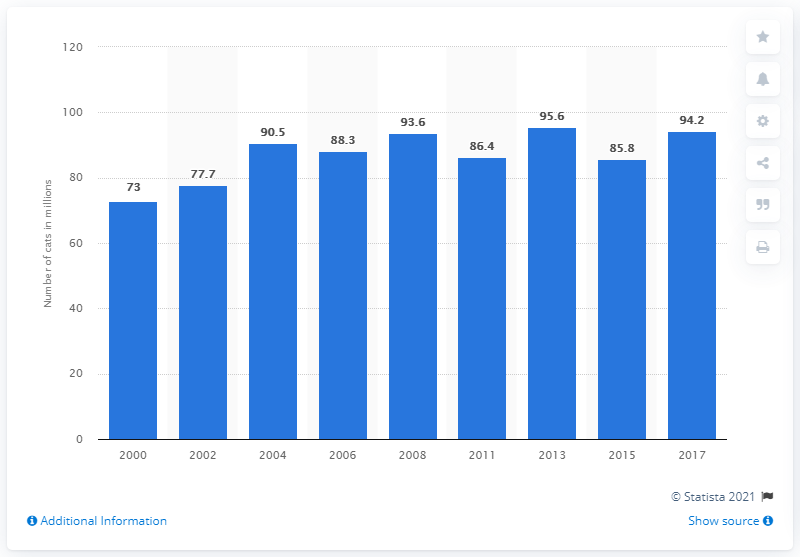Outline some significant characteristics in this image. In 2017, there were 95.6 million households in the United States that owned cats. 